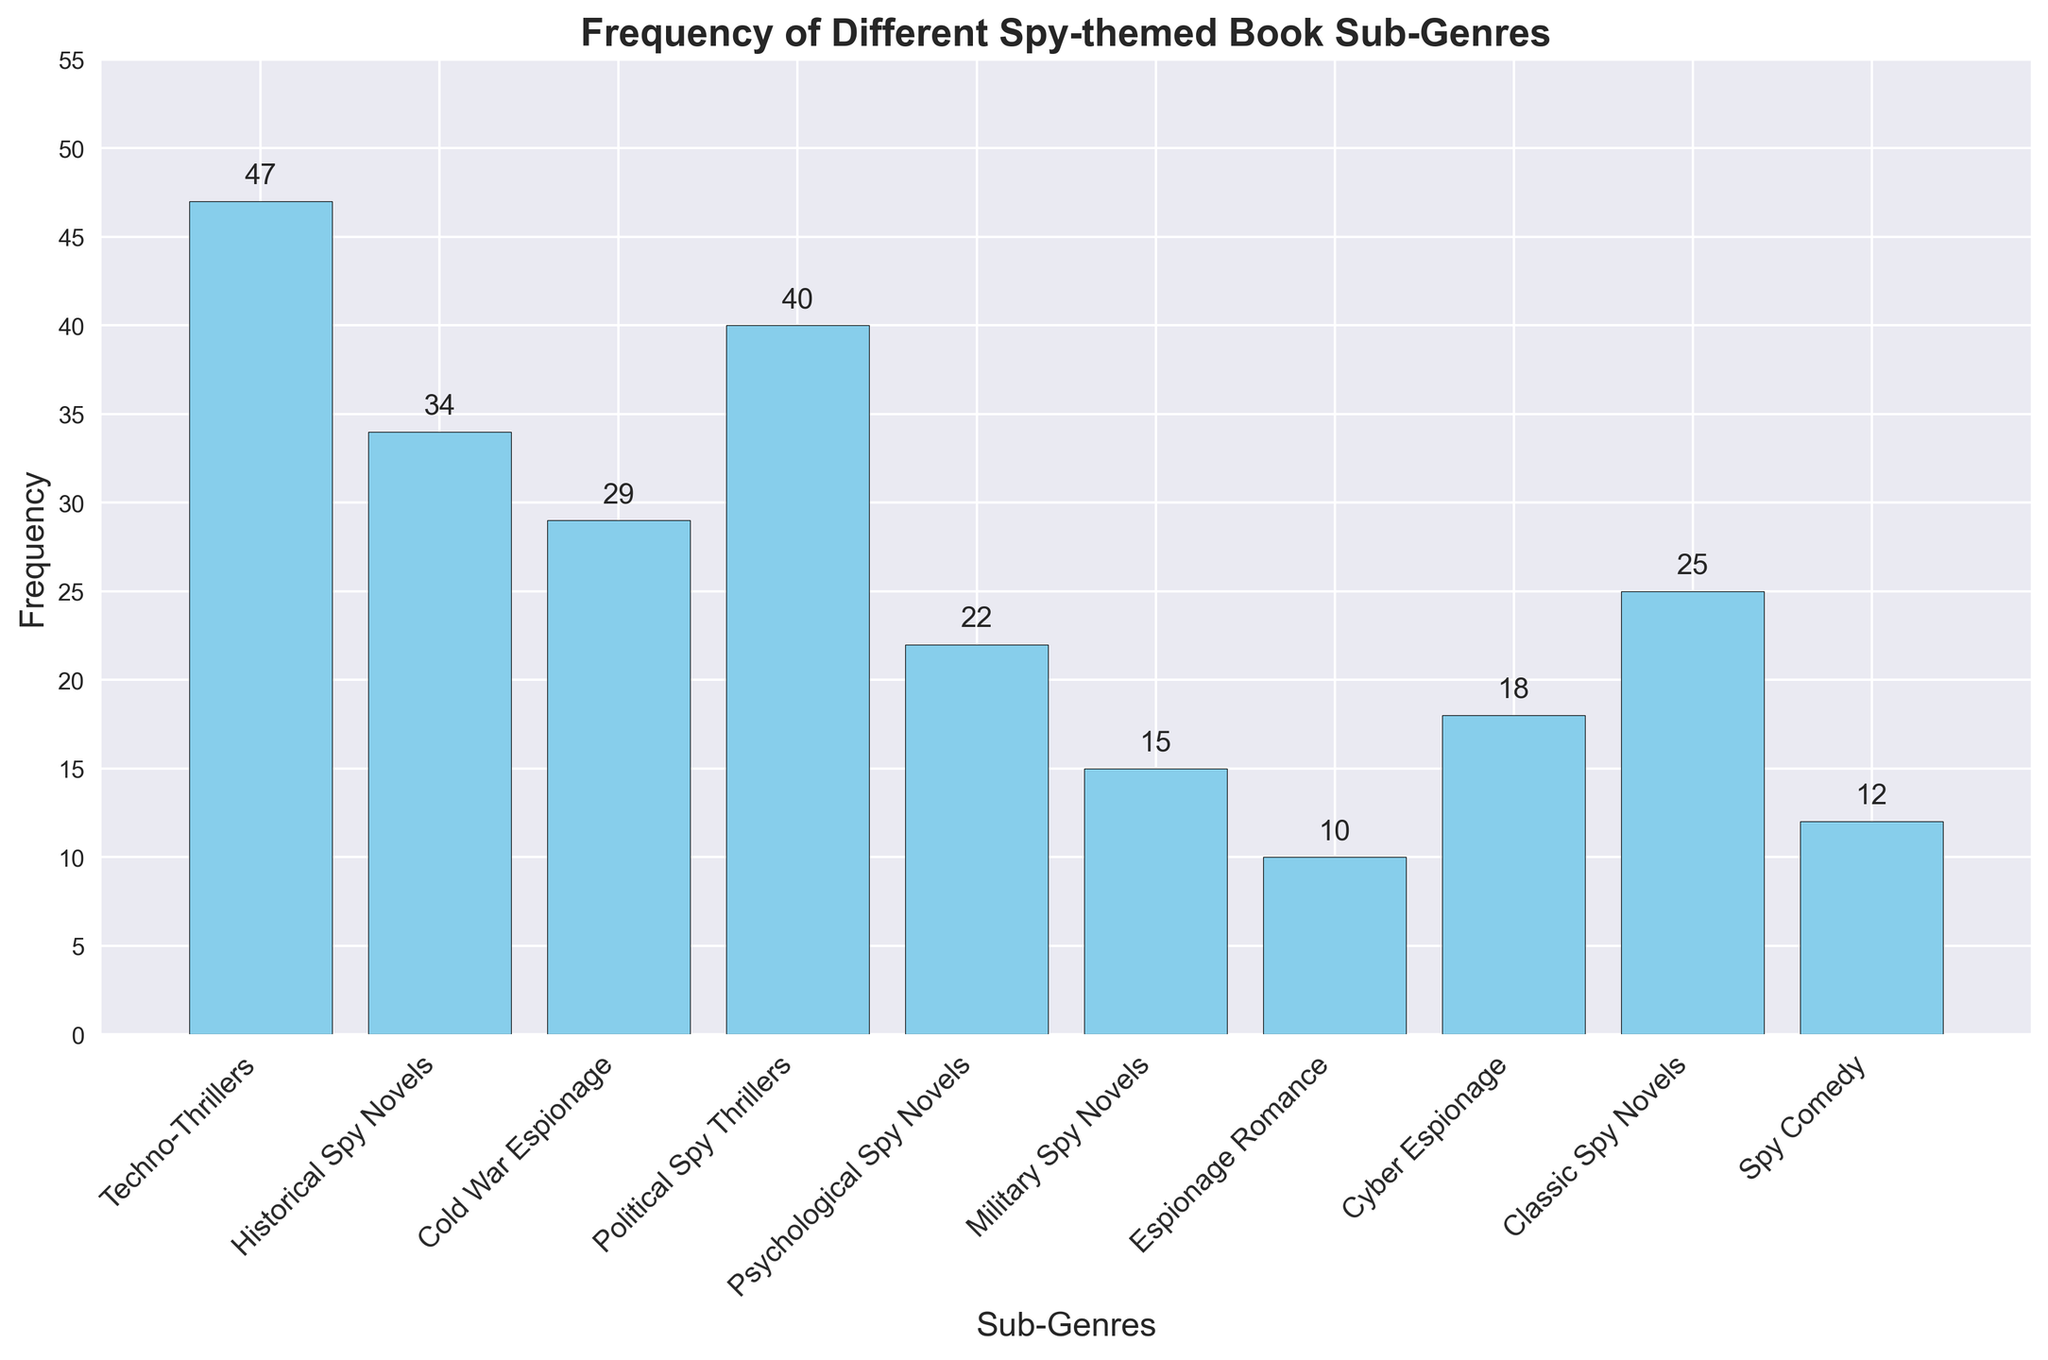What's the most frequent sub-genre of spy-themed books? The histogram shows the frequency of different sub-genres. By identifying the tallest bar in the chart, we can see that Techno-Thrillers has the highest frequency at 47.
Answer: Techno-Thrillers Which sub-genre has fewer books, Military Spy Novels or Spy Comedy? By comparing the heights of the bars for both sub-genres, we find that Military Spy Novels has a frequency of 15 and Spy Comedy has a frequency of 12. Therefore, Spy Comedy has fewer books.
Answer: Spy Comedy How many books are there in total for Psychological Spy Novels and Espionage Romance combined? The frequencies for Psychological Spy Novels and Espionage Romance are 22 and 10, respectively. Adding these together gives 22 + 10 = 32.
Answer: 32 Are there more Historical Spy Novels or Cyber Espionage books? By examining their corresponding bars, Historical Spy Novels has a frequency of 34, while Cyber Espionage has 18. Hence, there are more Historical Spy Novels.
Answer: Historical Spy Novels What is the difference in frequency between Political Spy Thrillers and Classic Spy Novels? The frequency of Political Spy Thrillers is 40 while Classic Spy Novels is 25. Subtracting these gives 40 - 25 = 15.
Answer: 15 What is the average frequency of the sub-genres with the top four highest frequencies? First, identify the top four frequencies: Techno-Thrillers (47), Political Spy Thrillers (40), Historical Spy Novels (34), and Cold War Espionage (29). Adding these gives 47 + 40 + 34 + 29 = 150. Dividing by 4 gives 150 / 4 = 37.5.
Answer: 37.5 Which sub-genre has the second-lowest frequency? By looking at the histogram, Espionage Romance has the lowest frequency at 10, and Spy Comedy has the second-lowest at 12.
Answer: Spy Comedy How many more books are there in the Techno-Thrillers sub-genre compared to Cyber Espionage? The frequency of Techno-Thrillers is 47, while Cyber Espionage is 18. The difference is 47 - 18 = 29.
Answer: 29 